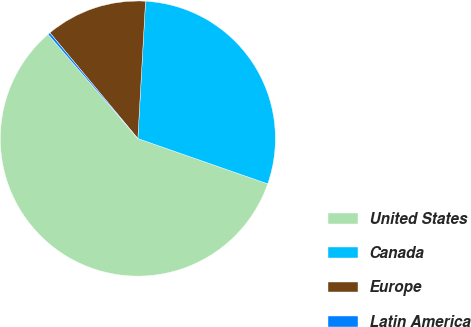Convert chart. <chart><loc_0><loc_0><loc_500><loc_500><pie_chart><fcel>United States<fcel>Canada<fcel>Europe<fcel>Latin America<nl><fcel>58.34%<fcel>29.45%<fcel>11.93%<fcel>0.28%<nl></chart> 